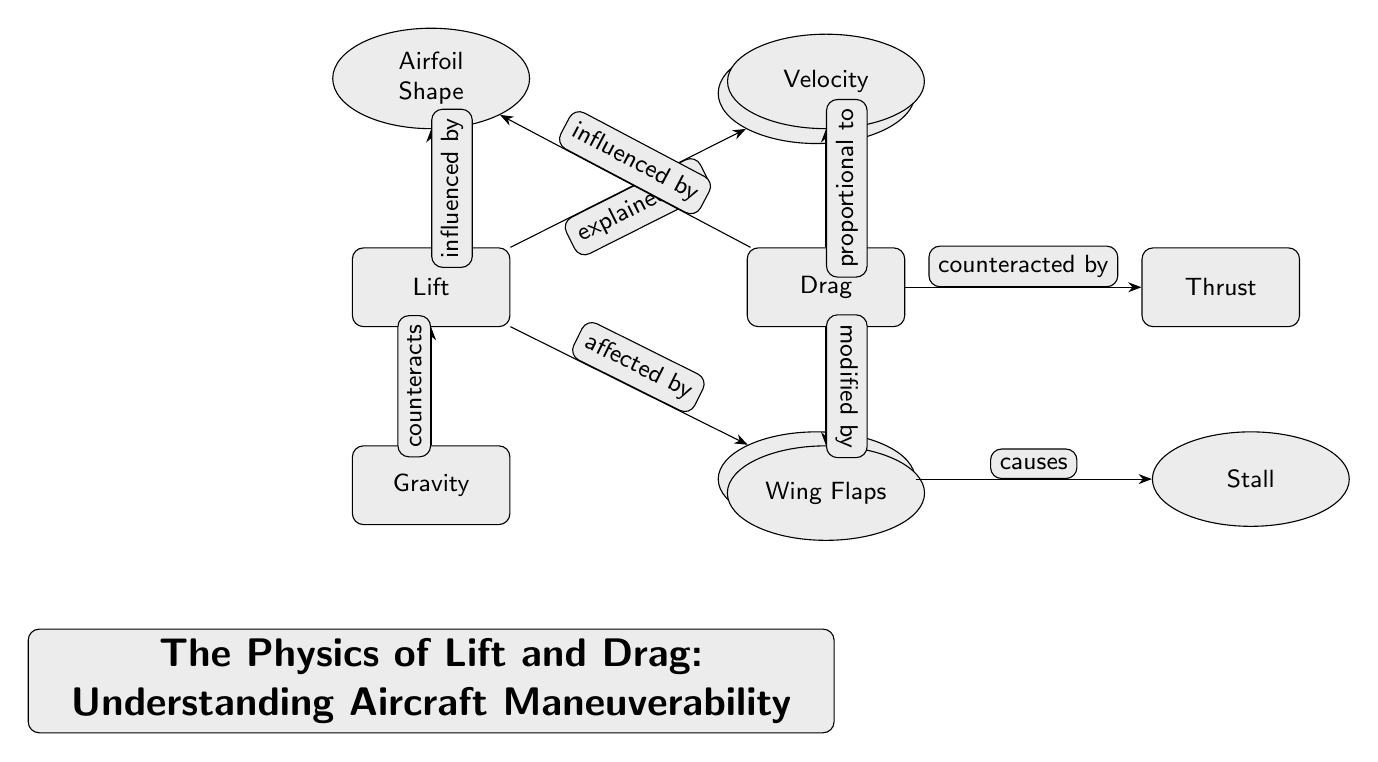What is the main focus of the diagram? The title at the bottom of the diagram clearly states the main focus, which is "The Physics of Lift and Drag: Understanding Aircraft Maneuverability." This indicates the primary topic represented in the diagram.
Answer: The Physics of Lift and Drag: Understanding Aircraft Maneuverability How many main nodes are displayed in the diagram? By counting the distinct main nodes, we find "Lift," "Drag," "Thrust," and "Gravity," which totals four main nodes.
Answer: 4 What principle is Lift explained by? Lift is directly connected to the node labeled "Bernoulli's Principle," which indicates that this principle explains how lift is generated.
Answer: Bernoulli's Principle What factor causes Stall? The diagram indicates that the "Angle of Attack" causes "Stall," establishing a cause-and-effect relationship that is depicted in the diagram.
Answer: Angle of Attack Which force counteracts Lift? The diagram shows that "Gravity" counteracts "Lift," illustrating the opposing nature of these two forces in the context of flight.
Answer: Gravity How is Drag influenced according to the diagram? "Drag" is influenced by the "Airfoil Shape," which is shown in the diagram as a direct relationship between these two components.
Answer: Airfoil Shape What modifies Drag? The diagram indicates that "Flaps" modify "Drag," highlighting how adjustments to flaps can impact the drag experienced by an aircraft.
Answer: Wing Flaps What is the relationship between Drag and Thrust? The diagram states that "Thrust" counteracts "Drag," establishing a relationship where thrust is necessary to overcome drag for sustained flight.
Answer: counteracted by Thrust What is Drag proportional to? The diagram specifies that "Drag" is proportional to "Velocity," indicating that as velocity increases, drag also increases.
Answer: Velocity 